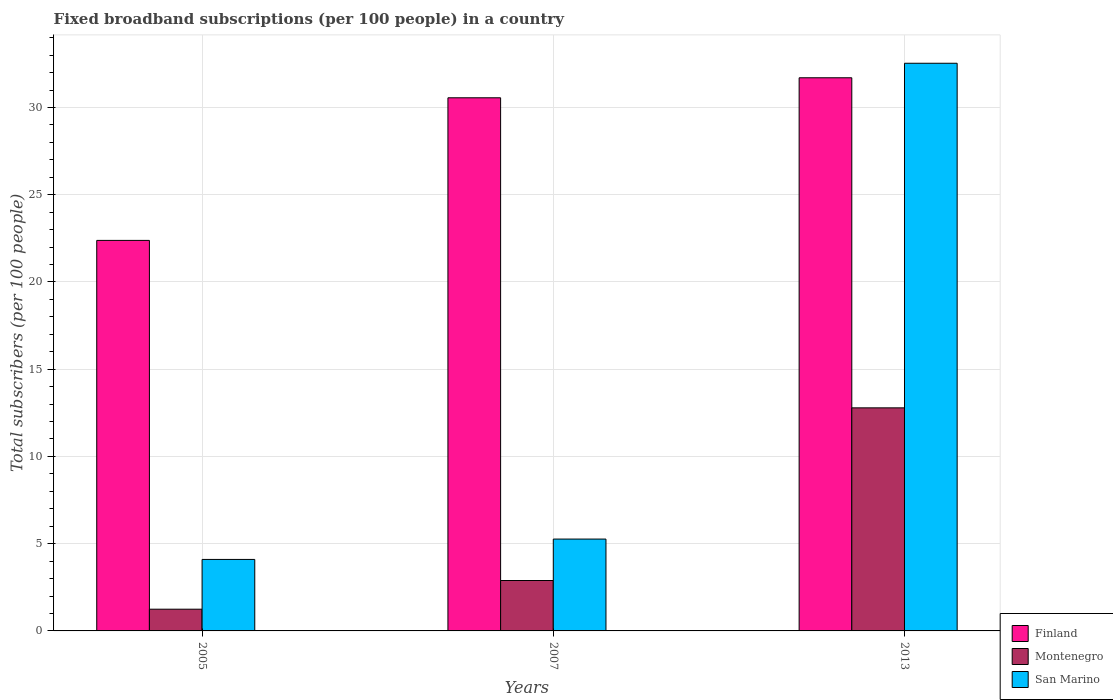How many groups of bars are there?
Your answer should be compact. 3. Are the number of bars per tick equal to the number of legend labels?
Give a very brief answer. Yes. What is the number of broadband subscriptions in San Marino in 2007?
Provide a succinct answer. 5.26. Across all years, what is the maximum number of broadband subscriptions in Finland?
Ensure brevity in your answer.  31.7. Across all years, what is the minimum number of broadband subscriptions in San Marino?
Make the answer very short. 4.1. What is the total number of broadband subscriptions in Montenegro in the graph?
Make the answer very short. 16.92. What is the difference between the number of broadband subscriptions in Montenegro in 2005 and that in 2013?
Offer a terse response. -11.54. What is the difference between the number of broadband subscriptions in San Marino in 2005 and the number of broadband subscriptions in Finland in 2013?
Ensure brevity in your answer.  -27.6. What is the average number of broadband subscriptions in Finland per year?
Your answer should be very brief. 28.21. In the year 2007, what is the difference between the number of broadband subscriptions in Montenegro and number of broadband subscriptions in San Marino?
Provide a short and direct response. -2.37. What is the ratio of the number of broadband subscriptions in Montenegro in 2005 to that in 2013?
Keep it short and to the point. 0.1. Is the number of broadband subscriptions in San Marino in 2005 less than that in 2007?
Provide a succinct answer. Yes. What is the difference between the highest and the second highest number of broadband subscriptions in San Marino?
Offer a very short reply. 27.27. What is the difference between the highest and the lowest number of broadband subscriptions in Finland?
Offer a very short reply. 9.32. In how many years, is the number of broadband subscriptions in Montenegro greater than the average number of broadband subscriptions in Montenegro taken over all years?
Offer a terse response. 1. Is the sum of the number of broadband subscriptions in Montenegro in 2005 and 2007 greater than the maximum number of broadband subscriptions in San Marino across all years?
Offer a very short reply. No. What does the 2nd bar from the right in 2005 represents?
Your answer should be compact. Montenegro. Are all the bars in the graph horizontal?
Ensure brevity in your answer.  No. What is the difference between two consecutive major ticks on the Y-axis?
Your response must be concise. 5. Does the graph contain any zero values?
Your answer should be compact. No. Does the graph contain grids?
Your answer should be very brief. Yes. How many legend labels are there?
Make the answer very short. 3. How are the legend labels stacked?
Ensure brevity in your answer.  Vertical. What is the title of the graph?
Keep it short and to the point. Fixed broadband subscriptions (per 100 people) in a country. What is the label or title of the Y-axis?
Ensure brevity in your answer.  Total subscribers (per 100 people). What is the Total subscribers (per 100 people) in Finland in 2005?
Provide a short and direct response. 22.38. What is the Total subscribers (per 100 people) of Montenegro in 2005?
Keep it short and to the point. 1.24. What is the Total subscribers (per 100 people) in San Marino in 2005?
Give a very brief answer. 4.1. What is the Total subscribers (per 100 people) in Finland in 2007?
Your answer should be very brief. 30.55. What is the Total subscribers (per 100 people) in Montenegro in 2007?
Your answer should be very brief. 2.89. What is the Total subscribers (per 100 people) in San Marino in 2007?
Provide a short and direct response. 5.26. What is the Total subscribers (per 100 people) in Finland in 2013?
Ensure brevity in your answer.  31.7. What is the Total subscribers (per 100 people) of Montenegro in 2013?
Offer a very short reply. 12.78. What is the Total subscribers (per 100 people) of San Marino in 2013?
Offer a very short reply. 32.53. Across all years, what is the maximum Total subscribers (per 100 people) of Finland?
Your answer should be compact. 31.7. Across all years, what is the maximum Total subscribers (per 100 people) in Montenegro?
Your answer should be compact. 12.78. Across all years, what is the maximum Total subscribers (per 100 people) in San Marino?
Offer a terse response. 32.53. Across all years, what is the minimum Total subscribers (per 100 people) of Finland?
Give a very brief answer. 22.38. Across all years, what is the minimum Total subscribers (per 100 people) of Montenegro?
Ensure brevity in your answer.  1.24. Across all years, what is the minimum Total subscribers (per 100 people) in San Marino?
Offer a terse response. 4.1. What is the total Total subscribers (per 100 people) in Finland in the graph?
Provide a short and direct response. 84.64. What is the total Total subscribers (per 100 people) of Montenegro in the graph?
Offer a very short reply. 16.92. What is the total Total subscribers (per 100 people) in San Marino in the graph?
Your answer should be very brief. 41.89. What is the difference between the Total subscribers (per 100 people) of Finland in 2005 and that in 2007?
Offer a terse response. -8.17. What is the difference between the Total subscribers (per 100 people) in Montenegro in 2005 and that in 2007?
Keep it short and to the point. -1.64. What is the difference between the Total subscribers (per 100 people) in San Marino in 2005 and that in 2007?
Offer a very short reply. -1.17. What is the difference between the Total subscribers (per 100 people) in Finland in 2005 and that in 2013?
Your response must be concise. -9.32. What is the difference between the Total subscribers (per 100 people) of Montenegro in 2005 and that in 2013?
Offer a terse response. -11.54. What is the difference between the Total subscribers (per 100 people) of San Marino in 2005 and that in 2013?
Give a very brief answer. -28.44. What is the difference between the Total subscribers (per 100 people) in Finland in 2007 and that in 2013?
Ensure brevity in your answer.  -1.15. What is the difference between the Total subscribers (per 100 people) in Montenegro in 2007 and that in 2013?
Keep it short and to the point. -9.89. What is the difference between the Total subscribers (per 100 people) in San Marino in 2007 and that in 2013?
Your response must be concise. -27.27. What is the difference between the Total subscribers (per 100 people) of Finland in 2005 and the Total subscribers (per 100 people) of Montenegro in 2007?
Your response must be concise. 19.49. What is the difference between the Total subscribers (per 100 people) of Finland in 2005 and the Total subscribers (per 100 people) of San Marino in 2007?
Ensure brevity in your answer.  17.12. What is the difference between the Total subscribers (per 100 people) in Montenegro in 2005 and the Total subscribers (per 100 people) in San Marino in 2007?
Keep it short and to the point. -4.02. What is the difference between the Total subscribers (per 100 people) in Finland in 2005 and the Total subscribers (per 100 people) in Montenegro in 2013?
Provide a short and direct response. 9.6. What is the difference between the Total subscribers (per 100 people) of Finland in 2005 and the Total subscribers (per 100 people) of San Marino in 2013?
Your response must be concise. -10.15. What is the difference between the Total subscribers (per 100 people) of Montenegro in 2005 and the Total subscribers (per 100 people) of San Marino in 2013?
Provide a succinct answer. -31.29. What is the difference between the Total subscribers (per 100 people) in Finland in 2007 and the Total subscribers (per 100 people) in Montenegro in 2013?
Keep it short and to the point. 17.77. What is the difference between the Total subscribers (per 100 people) in Finland in 2007 and the Total subscribers (per 100 people) in San Marino in 2013?
Your response must be concise. -1.98. What is the difference between the Total subscribers (per 100 people) in Montenegro in 2007 and the Total subscribers (per 100 people) in San Marino in 2013?
Your answer should be very brief. -29.64. What is the average Total subscribers (per 100 people) in Finland per year?
Provide a succinct answer. 28.21. What is the average Total subscribers (per 100 people) of Montenegro per year?
Your answer should be very brief. 5.64. What is the average Total subscribers (per 100 people) of San Marino per year?
Your response must be concise. 13.96. In the year 2005, what is the difference between the Total subscribers (per 100 people) of Finland and Total subscribers (per 100 people) of Montenegro?
Ensure brevity in your answer.  21.14. In the year 2005, what is the difference between the Total subscribers (per 100 people) of Finland and Total subscribers (per 100 people) of San Marino?
Your response must be concise. 18.28. In the year 2005, what is the difference between the Total subscribers (per 100 people) in Montenegro and Total subscribers (per 100 people) in San Marino?
Your response must be concise. -2.85. In the year 2007, what is the difference between the Total subscribers (per 100 people) in Finland and Total subscribers (per 100 people) in Montenegro?
Your answer should be very brief. 27.66. In the year 2007, what is the difference between the Total subscribers (per 100 people) in Finland and Total subscribers (per 100 people) in San Marino?
Offer a terse response. 25.29. In the year 2007, what is the difference between the Total subscribers (per 100 people) in Montenegro and Total subscribers (per 100 people) in San Marino?
Give a very brief answer. -2.37. In the year 2013, what is the difference between the Total subscribers (per 100 people) of Finland and Total subscribers (per 100 people) of Montenegro?
Give a very brief answer. 18.92. In the year 2013, what is the difference between the Total subscribers (per 100 people) in Finland and Total subscribers (per 100 people) in San Marino?
Offer a very short reply. -0.83. In the year 2013, what is the difference between the Total subscribers (per 100 people) in Montenegro and Total subscribers (per 100 people) in San Marino?
Offer a very short reply. -19.75. What is the ratio of the Total subscribers (per 100 people) in Finland in 2005 to that in 2007?
Give a very brief answer. 0.73. What is the ratio of the Total subscribers (per 100 people) in Montenegro in 2005 to that in 2007?
Your response must be concise. 0.43. What is the ratio of the Total subscribers (per 100 people) of San Marino in 2005 to that in 2007?
Keep it short and to the point. 0.78. What is the ratio of the Total subscribers (per 100 people) in Finland in 2005 to that in 2013?
Make the answer very short. 0.71. What is the ratio of the Total subscribers (per 100 people) in Montenegro in 2005 to that in 2013?
Your answer should be very brief. 0.1. What is the ratio of the Total subscribers (per 100 people) in San Marino in 2005 to that in 2013?
Give a very brief answer. 0.13. What is the ratio of the Total subscribers (per 100 people) of Finland in 2007 to that in 2013?
Your answer should be compact. 0.96. What is the ratio of the Total subscribers (per 100 people) in Montenegro in 2007 to that in 2013?
Give a very brief answer. 0.23. What is the ratio of the Total subscribers (per 100 people) in San Marino in 2007 to that in 2013?
Provide a short and direct response. 0.16. What is the difference between the highest and the second highest Total subscribers (per 100 people) of Finland?
Make the answer very short. 1.15. What is the difference between the highest and the second highest Total subscribers (per 100 people) of Montenegro?
Give a very brief answer. 9.89. What is the difference between the highest and the second highest Total subscribers (per 100 people) of San Marino?
Give a very brief answer. 27.27. What is the difference between the highest and the lowest Total subscribers (per 100 people) in Finland?
Keep it short and to the point. 9.32. What is the difference between the highest and the lowest Total subscribers (per 100 people) in Montenegro?
Your answer should be compact. 11.54. What is the difference between the highest and the lowest Total subscribers (per 100 people) in San Marino?
Make the answer very short. 28.44. 